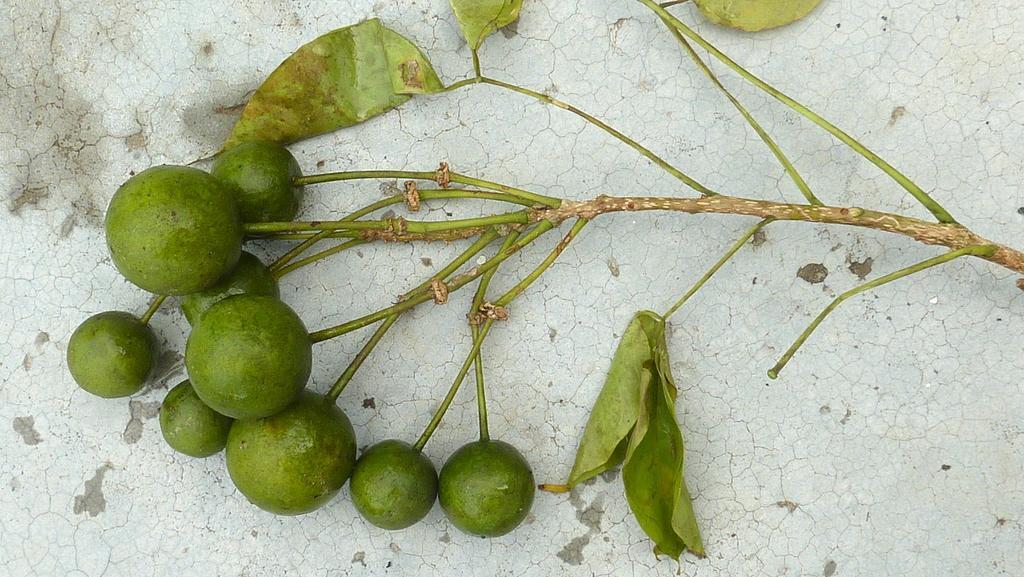How would you summarize this image in a sentence or two? Here we can see fruits and leaves to a stem on a platform. 